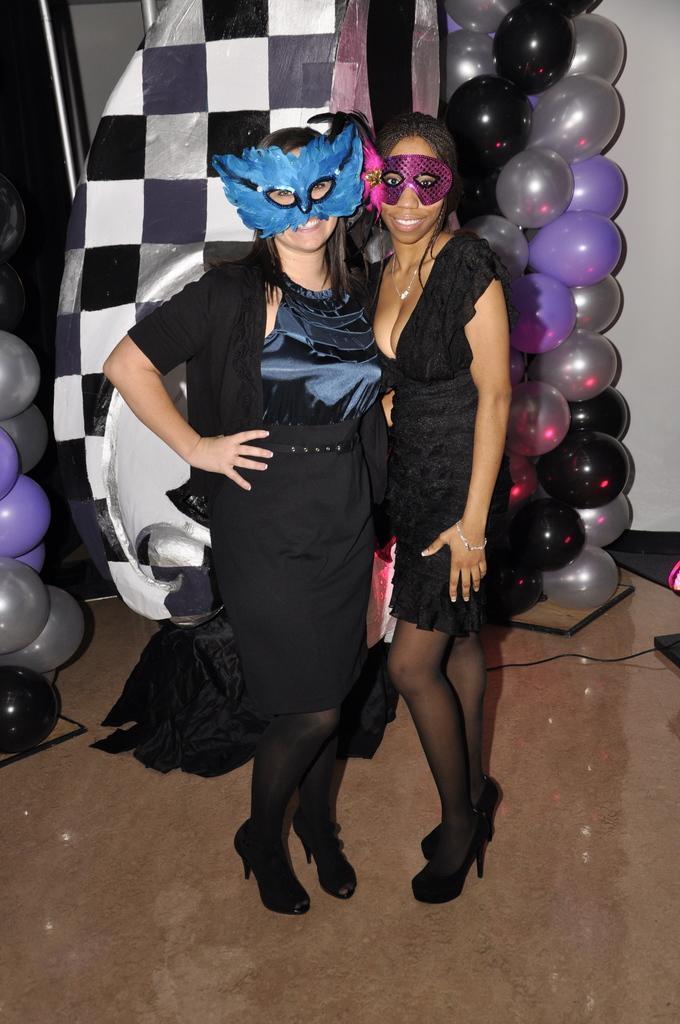Describe this image in one or two sentences. In this image I can see two women wearing black colored dresses are standing. I can see one of the women is wearing blue colored mask and the other is wearing pink colored mask. In the background I can see few balloons which are black, silver and violet in color and I can see the brown colored floor and the white colored wall. 